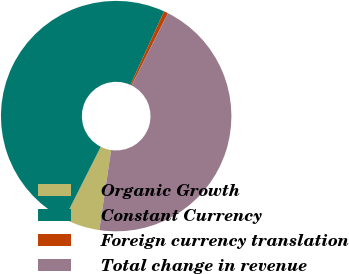<chart> <loc_0><loc_0><loc_500><loc_500><pie_chart><fcel>Organic Growth<fcel>Constant Currency<fcel>Foreign currency translation<fcel>Total change in revenue<nl><fcel>5.08%<fcel>49.41%<fcel>0.59%<fcel>44.92%<nl></chart> 